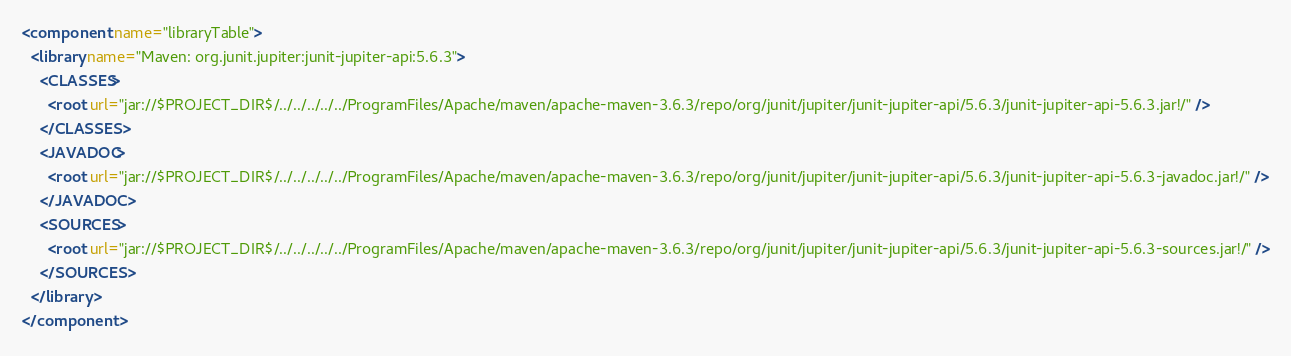Convert code to text. <code><loc_0><loc_0><loc_500><loc_500><_XML_><component name="libraryTable">
  <library name="Maven: org.junit.jupiter:junit-jupiter-api:5.6.3">
    <CLASSES>
      <root url="jar://$PROJECT_DIR$/../../../../../ProgramFiles/Apache/maven/apache-maven-3.6.3/repo/org/junit/jupiter/junit-jupiter-api/5.6.3/junit-jupiter-api-5.6.3.jar!/" />
    </CLASSES>
    <JAVADOC>
      <root url="jar://$PROJECT_DIR$/../../../../../ProgramFiles/Apache/maven/apache-maven-3.6.3/repo/org/junit/jupiter/junit-jupiter-api/5.6.3/junit-jupiter-api-5.6.3-javadoc.jar!/" />
    </JAVADOC>
    <SOURCES>
      <root url="jar://$PROJECT_DIR$/../../../../../ProgramFiles/Apache/maven/apache-maven-3.6.3/repo/org/junit/jupiter/junit-jupiter-api/5.6.3/junit-jupiter-api-5.6.3-sources.jar!/" />
    </SOURCES>
  </library>
</component></code> 